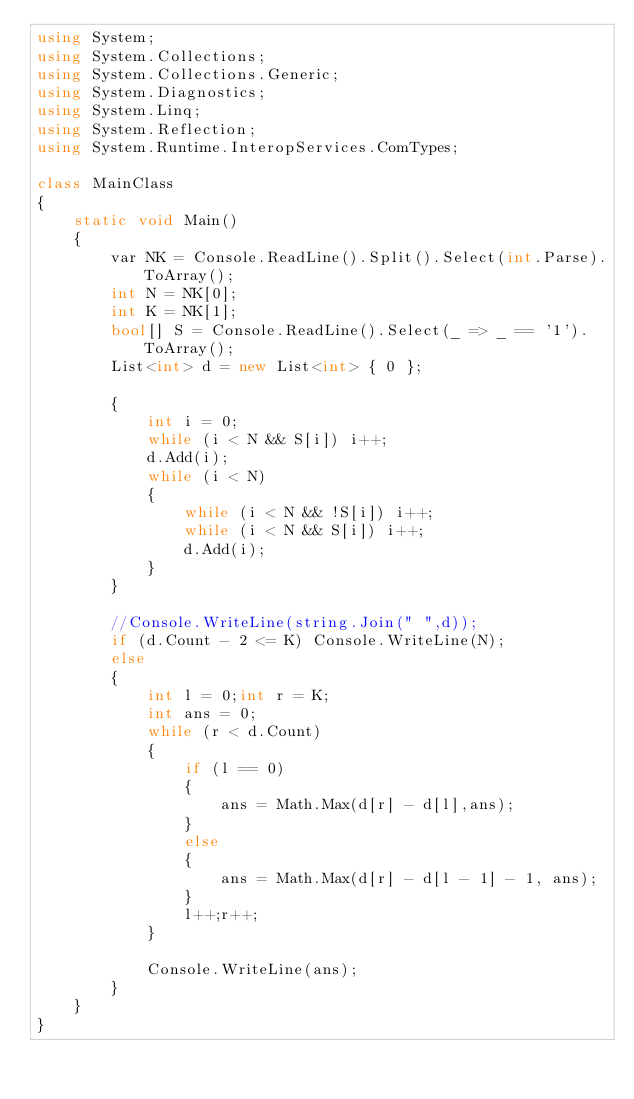<code> <loc_0><loc_0><loc_500><loc_500><_C#_>using System;
using System.Collections;
using System.Collections.Generic;
using System.Diagnostics;
using System.Linq;
using System.Reflection;
using System.Runtime.InteropServices.ComTypes;

class MainClass
{
    static void Main()
    {
        var NK = Console.ReadLine().Split().Select(int.Parse).ToArray();
        int N = NK[0];
        int K = NK[1];
        bool[] S = Console.ReadLine().Select(_ => _ == '1').ToArray();
        List<int> d = new List<int> { 0 };

        {
            int i = 0;
            while (i < N && S[i]) i++;
            d.Add(i);
            while (i < N)
            {
                while (i < N && !S[i]) i++;
                while (i < N && S[i]) i++;
                d.Add(i);
            }
        }

        //Console.WriteLine(string.Join(" ",d));
        if (d.Count - 2 <= K) Console.WriteLine(N);
        else
        {
            int l = 0;int r = K;
            int ans = 0;
            while (r < d.Count)
            {
                if (l == 0)
                {
                    ans = Math.Max(d[r] - d[l],ans);
                }
                else
                {
                    ans = Math.Max(d[r] - d[l - 1] - 1, ans);
                }
                l++;r++;
            }

            Console.WriteLine(ans);
        }
    }
}</code> 